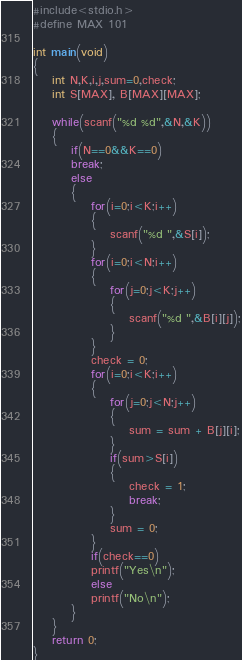<code> <loc_0><loc_0><loc_500><loc_500><_C_>#include<stdio.h>
#define MAX 101

int main(void)
{
	int N,K,i,j,sum=0,check;
	int S[MAX], B[MAX][MAX];
	
	while(scanf("%d %d",&N,&K))
	{
		if(N==0&&K==0)
		break;
		else
		{
			for(i=0;i<K;i++)
			{
				scanf("%d ",&S[i]);
			}
			for(i=0;i<N;i++)
			{
				for(j=0;j<K;j++)
				{
					scanf("%d ",&B[i][j]);
				}
			}
			check = 0;
			for(i=0;i<K;i++)
			{
				for(j=0;j<N;j++)
				{
					sum = sum + B[j][i];
				}
				if(sum>S[i])
				{
					check = 1;
					break;
				}
				sum = 0;
			}
			if(check==0)
			printf("Yes\n");
			else
			printf("No\n");
		}
	}
	return 0;
}</code> 